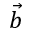<formula> <loc_0><loc_0><loc_500><loc_500>\vec { b }</formula> 